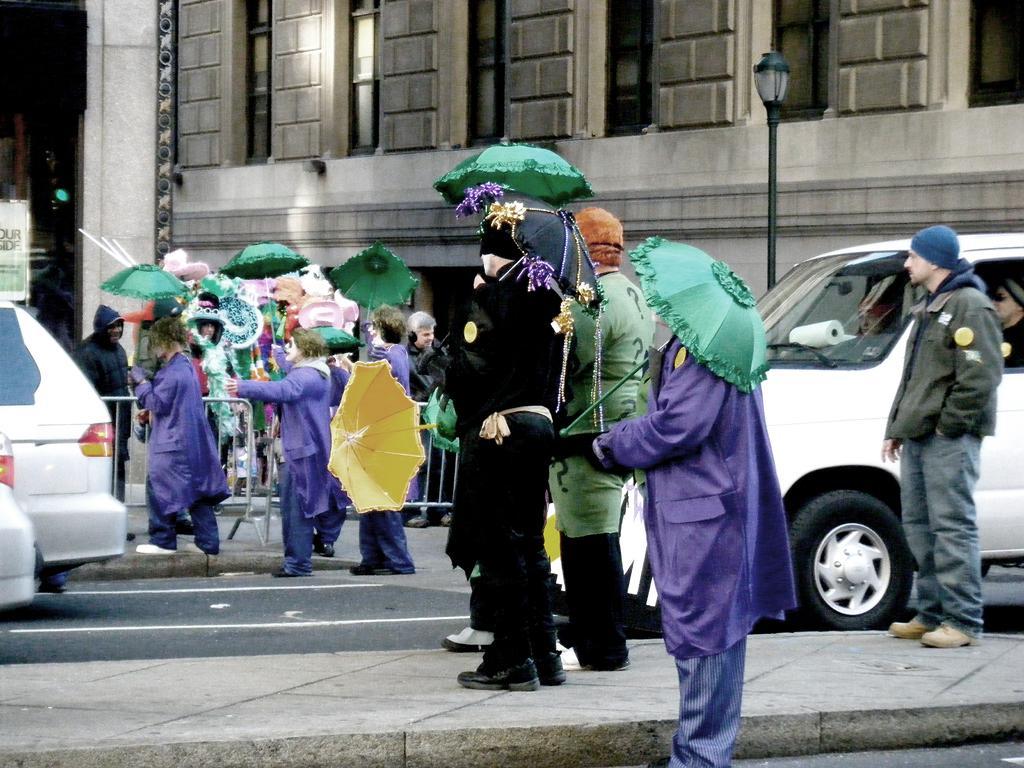Describe this image in one or two sentences. In this image there are a group of people some of them are standing and some of them are walking and on the right side and left side there are some cars and one pole is there, and on the background there is one building and on the left side there is one board. 